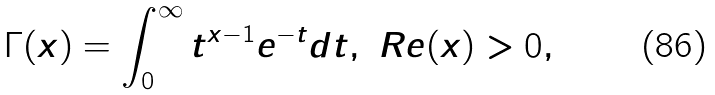Convert formula to latex. <formula><loc_0><loc_0><loc_500><loc_500>\Gamma ( x ) = \int _ { 0 } ^ { \infty } t ^ { x - 1 } e ^ { - t } d t , \ R e ( x ) > 0 ,</formula> 